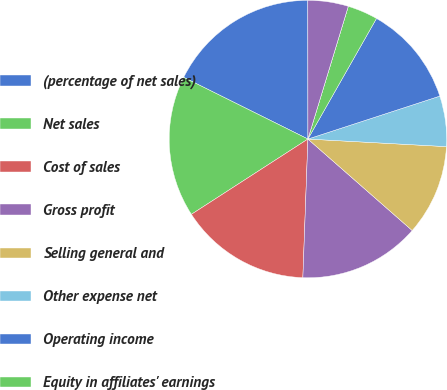<chart> <loc_0><loc_0><loc_500><loc_500><pie_chart><fcel>(percentage of net sales)<fcel>Net sales<fcel>Cost of sales<fcel>Gross profit<fcel>Selling general and<fcel>Other expense net<fcel>Operating income<fcel>Equity in affiliates' earnings<fcel>Interest income<fcel>Interest expense and finance<nl><fcel>17.65%<fcel>16.47%<fcel>15.29%<fcel>14.12%<fcel>10.59%<fcel>5.88%<fcel>11.76%<fcel>3.53%<fcel>0.0%<fcel>4.71%<nl></chart> 